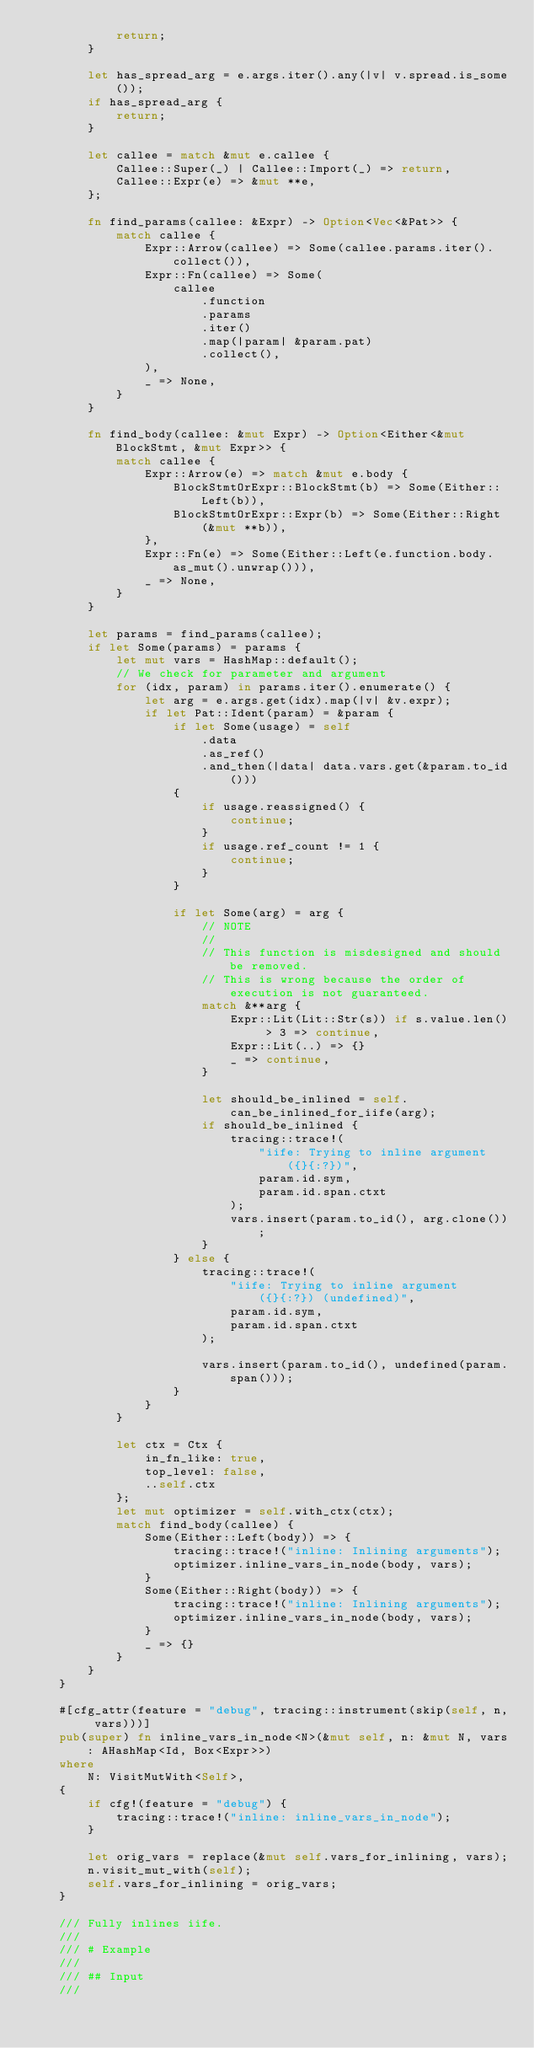<code> <loc_0><loc_0><loc_500><loc_500><_Rust_>            return;
        }

        let has_spread_arg = e.args.iter().any(|v| v.spread.is_some());
        if has_spread_arg {
            return;
        }

        let callee = match &mut e.callee {
            Callee::Super(_) | Callee::Import(_) => return,
            Callee::Expr(e) => &mut **e,
        };

        fn find_params(callee: &Expr) -> Option<Vec<&Pat>> {
            match callee {
                Expr::Arrow(callee) => Some(callee.params.iter().collect()),
                Expr::Fn(callee) => Some(
                    callee
                        .function
                        .params
                        .iter()
                        .map(|param| &param.pat)
                        .collect(),
                ),
                _ => None,
            }
        }

        fn find_body(callee: &mut Expr) -> Option<Either<&mut BlockStmt, &mut Expr>> {
            match callee {
                Expr::Arrow(e) => match &mut e.body {
                    BlockStmtOrExpr::BlockStmt(b) => Some(Either::Left(b)),
                    BlockStmtOrExpr::Expr(b) => Some(Either::Right(&mut **b)),
                },
                Expr::Fn(e) => Some(Either::Left(e.function.body.as_mut().unwrap())),
                _ => None,
            }
        }

        let params = find_params(callee);
        if let Some(params) = params {
            let mut vars = HashMap::default();
            // We check for parameter and argument
            for (idx, param) in params.iter().enumerate() {
                let arg = e.args.get(idx).map(|v| &v.expr);
                if let Pat::Ident(param) = &param {
                    if let Some(usage) = self
                        .data
                        .as_ref()
                        .and_then(|data| data.vars.get(&param.to_id()))
                    {
                        if usage.reassigned() {
                            continue;
                        }
                        if usage.ref_count != 1 {
                            continue;
                        }
                    }

                    if let Some(arg) = arg {
                        // NOTE
                        //
                        // This function is misdesigned and should be removed.
                        // This is wrong because the order of execution is not guaranteed.
                        match &**arg {
                            Expr::Lit(Lit::Str(s)) if s.value.len() > 3 => continue,
                            Expr::Lit(..) => {}
                            _ => continue,
                        }

                        let should_be_inlined = self.can_be_inlined_for_iife(arg);
                        if should_be_inlined {
                            tracing::trace!(
                                "iife: Trying to inline argument ({}{:?})",
                                param.id.sym,
                                param.id.span.ctxt
                            );
                            vars.insert(param.to_id(), arg.clone());
                        }
                    } else {
                        tracing::trace!(
                            "iife: Trying to inline argument ({}{:?}) (undefined)",
                            param.id.sym,
                            param.id.span.ctxt
                        );

                        vars.insert(param.to_id(), undefined(param.span()));
                    }
                }
            }

            let ctx = Ctx {
                in_fn_like: true,
                top_level: false,
                ..self.ctx
            };
            let mut optimizer = self.with_ctx(ctx);
            match find_body(callee) {
                Some(Either::Left(body)) => {
                    tracing::trace!("inline: Inlining arguments");
                    optimizer.inline_vars_in_node(body, vars);
                }
                Some(Either::Right(body)) => {
                    tracing::trace!("inline: Inlining arguments");
                    optimizer.inline_vars_in_node(body, vars);
                }
                _ => {}
            }
        }
    }

    #[cfg_attr(feature = "debug", tracing::instrument(skip(self, n, vars)))]
    pub(super) fn inline_vars_in_node<N>(&mut self, n: &mut N, vars: AHashMap<Id, Box<Expr>>)
    where
        N: VisitMutWith<Self>,
    {
        if cfg!(feature = "debug") {
            tracing::trace!("inline: inline_vars_in_node");
        }

        let orig_vars = replace(&mut self.vars_for_inlining, vars);
        n.visit_mut_with(self);
        self.vars_for_inlining = orig_vars;
    }

    /// Fully inlines iife.
    ///
    /// # Example
    ///
    /// ## Input
    ///</code> 